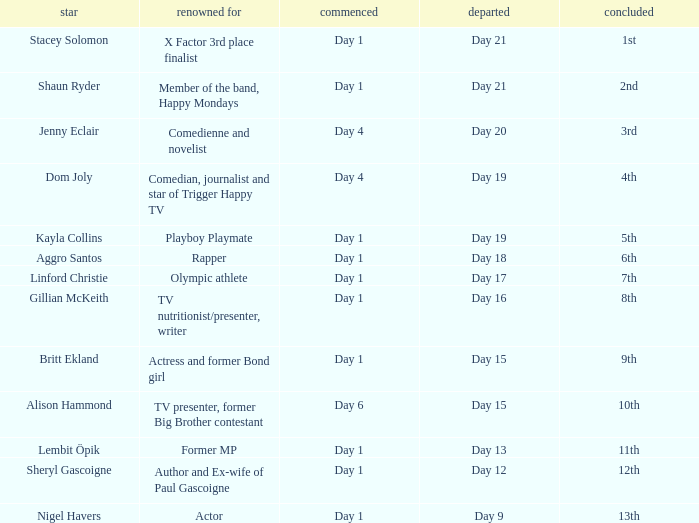What was Dom Joly famous for? Comedian, journalist and star of Trigger Happy TV. 